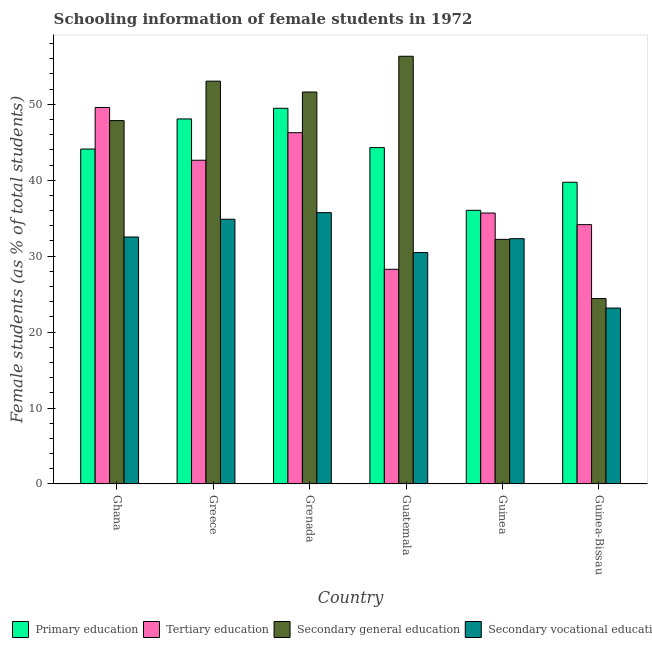Are the number of bars per tick equal to the number of legend labels?
Your answer should be very brief. Yes. Are the number of bars on each tick of the X-axis equal?
Make the answer very short. Yes. What is the label of the 6th group of bars from the left?
Give a very brief answer. Guinea-Bissau. In how many cases, is the number of bars for a given country not equal to the number of legend labels?
Your answer should be very brief. 0. What is the percentage of female students in secondary vocational education in Guinea?
Give a very brief answer. 32.31. Across all countries, what is the maximum percentage of female students in tertiary education?
Offer a very short reply. 49.59. Across all countries, what is the minimum percentage of female students in tertiary education?
Your response must be concise. 28.27. In which country was the percentage of female students in secondary education maximum?
Your answer should be compact. Guatemala. In which country was the percentage of female students in primary education minimum?
Provide a short and direct response. Guinea. What is the total percentage of female students in tertiary education in the graph?
Your response must be concise. 236.6. What is the difference between the percentage of female students in primary education in Greece and that in Guatemala?
Your answer should be compact. 3.78. What is the difference between the percentage of female students in primary education in Guinea and the percentage of female students in secondary education in Greece?
Offer a very short reply. -17.01. What is the average percentage of female students in primary education per country?
Ensure brevity in your answer.  43.62. What is the difference between the percentage of female students in primary education and percentage of female students in secondary education in Guinea-Bissau?
Give a very brief answer. 15.31. What is the ratio of the percentage of female students in primary education in Grenada to that in Guinea?
Give a very brief answer. 1.37. Is the percentage of female students in secondary education in Ghana less than that in Guinea-Bissau?
Make the answer very short. No. Is the difference between the percentage of female students in tertiary education in Ghana and Guatemala greater than the difference between the percentage of female students in primary education in Ghana and Guatemala?
Your answer should be compact. Yes. What is the difference between the highest and the second highest percentage of female students in tertiary education?
Provide a short and direct response. 3.32. What is the difference between the highest and the lowest percentage of female students in primary education?
Offer a very short reply. 13.44. In how many countries, is the percentage of female students in secondary education greater than the average percentage of female students in secondary education taken over all countries?
Provide a short and direct response. 4. Is the sum of the percentage of female students in secondary education in Grenada and Guinea greater than the maximum percentage of female students in primary education across all countries?
Make the answer very short. Yes. Is it the case that in every country, the sum of the percentage of female students in secondary vocational education and percentage of female students in secondary education is greater than the sum of percentage of female students in tertiary education and percentage of female students in primary education?
Offer a terse response. No. What does the 4th bar from the left in Greece represents?
Offer a terse response. Secondary vocational education. What does the 1st bar from the right in Guinea-Bissau represents?
Your response must be concise. Secondary vocational education. How many bars are there?
Offer a very short reply. 24. How many countries are there in the graph?
Offer a terse response. 6. Are the values on the major ticks of Y-axis written in scientific E-notation?
Give a very brief answer. No. Where does the legend appear in the graph?
Your response must be concise. Bottom left. How many legend labels are there?
Give a very brief answer. 4. What is the title of the graph?
Give a very brief answer. Schooling information of female students in 1972. What is the label or title of the Y-axis?
Offer a very short reply. Female students (as % of total students). What is the Female students (as % of total students) in Primary education in Ghana?
Provide a succinct answer. 44.11. What is the Female students (as % of total students) in Tertiary education in Ghana?
Give a very brief answer. 49.59. What is the Female students (as % of total students) of Secondary general education in Ghana?
Your answer should be very brief. 47.86. What is the Female students (as % of total students) of Secondary vocational education in Ghana?
Your answer should be compact. 32.53. What is the Female students (as % of total students) of Primary education in Greece?
Your answer should be very brief. 48.07. What is the Female students (as % of total students) in Tertiary education in Greece?
Provide a short and direct response. 42.64. What is the Female students (as % of total students) in Secondary general education in Greece?
Your response must be concise. 53.05. What is the Female students (as % of total students) of Secondary vocational education in Greece?
Offer a very short reply. 34.87. What is the Female students (as % of total students) of Primary education in Grenada?
Your answer should be very brief. 49.48. What is the Female students (as % of total students) of Tertiary education in Grenada?
Your response must be concise. 46.26. What is the Female students (as % of total students) in Secondary general education in Grenada?
Make the answer very short. 51.62. What is the Female students (as % of total students) in Secondary vocational education in Grenada?
Provide a short and direct response. 35.73. What is the Female students (as % of total students) of Primary education in Guatemala?
Ensure brevity in your answer.  44.3. What is the Female students (as % of total students) in Tertiary education in Guatemala?
Ensure brevity in your answer.  28.27. What is the Female students (as % of total students) of Secondary general education in Guatemala?
Offer a terse response. 56.33. What is the Female students (as % of total students) of Secondary vocational education in Guatemala?
Offer a terse response. 30.48. What is the Female students (as % of total students) of Primary education in Guinea?
Offer a very short reply. 36.04. What is the Female students (as % of total students) in Tertiary education in Guinea?
Your response must be concise. 35.68. What is the Female students (as % of total students) in Secondary general education in Guinea?
Make the answer very short. 32.21. What is the Female students (as % of total students) of Secondary vocational education in Guinea?
Offer a terse response. 32.31. What is the Female students (as % of total students) in Primary education in Guinea-Bissau?
Keep it short and to the point. 39.73. What is the Female students (as % of total students) in Tertiary education in Guinea-Bissau?
Provide a succinct answer. 34.15. What is the Female students (as % of total students) of Secondary general education in Guinea-Bissau?
Provide a short and direct response. 24.42. What is the Female students (as % of total students) of Secondary vocational education in Guinea-Bissau?
Offer a terse response. 23.17. Across all countries, what is the maximum Female students (as % of total students) in Primary education?
Your answer should be very brief. 49.48. Across all countries, what is the maximum Female students (as % of total students) of Tertiary education?
Make the answer very short. 49.59. Across all countries, what is the maximum Female students (as % of total students) in Secondary general education?
Your response must be concise. 56.33. Across all countries, what is the maximum Female students (as % of total students) of Secondary vocational education?
Offer a very short reply. 35.73. Across all countries, what is the minimum Female students (as % of total students) of Primary education?
Make the answer very short. 36.04. Across all countries, what is the minimum Female students (as % of total students) in Tertiary education?
Your answer should be compact. 28.27. Across all countries, what is the minimum Female students (as % of total students) of Secondary general education?
Give a very brief answer. 24.42. Across all countries, what is the minimum Female students (as % of total students) in Secondary vocational education?
Your answer should be very brief. 23.17. What is the total Female students (as % of total students) in Primary education in the graph?
Provide a short and direct response. 261.74. What is the total Female students (as % of total students) in Tertiary education in the graph?
Make the answer very short. 236.6. What is the total Female students (as % of total students) in Secondary general education in the graph?
Your response must be concise. 265.5. What is the total Female students (as % of total students) in Secondary vocational education in the graph?
Your answer should be compact. 189.08. What is the difference between the Female students (as % of total students) in Primary education in Ghana and that in Greece?
Offer a very short reply. -3.97. What is the difference between the Female students (as % of total students) in Tertiary education in Ghana and that in Greece?
Provide a succinct answer. 6.95. What is the difference between the Female students (as % of total students) in Secondary general education in Ghana and that in Greece?
Give a very brief answer. -5.19. What is the difference between the Female students (as % of total students) of Secondary vocational education in Ghana and that in Greece?
Offer a very short reply. -2.34. What is the difference between the Female students (as % of total students) of Primary education in Ghana and that in Grenada?
Your response must be concise. -5.37. What is the difference between the Female students (as % of total students) in Tertiary education in Ghana and that in Grenada?
Your answer should be very brief. 3.32. What is the difference between the Female students (as % of total students) of Secondary general education in Ghana and that in Grenada?
Your response must be concise. -3.76. What is the difference between the Female students (as % of total students) in Secondary vocational education in Ghana and that in Grenada?
Offer a terse response. -3.2. What is the difference between the Female students (as % of total students) of Primary education in Ghana and that in Guatemala?
Give a very brief answer. -0.19. What is the difference between the Female students (as % of total students) in Tertiary education in Ghana and that in Guatemala?
Your response must be concise. 21.31. What is the difference between the Female students (as % of total students) in Secondary general education in Ghana and that in Guatemala?
Offer a very short reply. -8.47. What is the difference between the Female students (as % of total students) of Secondary vocational education in Ghana and that in Guatemala?
Make the answer very short. 2.05. What is the difference between the Female students (as % of total students) of Primary education in Ghana and that in Guinea?
Provide a succinct answer. 8.07. What is the difference between the Female students (as % of total students) of Tertiary education in Ghana and that in Guinea?
Offer a terse response. 13.91. What is the difference between the Female students (as % of total students) in Secondary general education in Ghana and that in Guinea?
Provide a short and direct response. 15.64. What is the difference between the Female students (as % of total students) of Secondary vocational education in Ghana and that in Guinea?
Offer a very short reply. 0.22. What is the difference between the Female students (as % of total students) in Primary education in Ghana and that in Guinea-Bissau?
Make the answer very short. 4.37. What is the difference between the Female students (as % of total students) in Tertiary education in Ghana and that in Guinea-Bissau?
Your answer should be compact. 15.43. What is the difference between the Female students (as % of total students) of Secondary general education in Ghana and that in Guinea-Bissau?
Provide a succinct answer. 23.44. What is the difference between the Female students (as % of total students) of Secondary vocational education in Ghana and that in Guinea-Bissau?
Offer a very short reply. 9.36. What is the difference between the Female students (as % of total students) of Primary education in Greece and that in Grenada?
Your answer should be compact. -1.4. What is the difference between the Female students (as % of total students) in Tertiary education in Greece and that in Grenada?
Make the answer very short. -3.63. What is the difference between the Female students (as % of total students) in Secondary general education in Greece and that in Grenada?
Make the answer very short. 1.43. What is the difference between the Female students (as % of total students) in Secondary vocational education in Greece and that in Grenada?
Your answer should be compact. -0.87. What is the difference between the Female students (as % of total students) of Primary education in Greece and that in Guatemala?
Make the answer very short. 3.78. What is the difference between the Female students (as % of total students) in Tertiary education in Greece and that in Guatemala?
Your answer should be very brief. 14.36. What is the difference between the Female students (as % of total students) of Secondary general education in Greece and that in Guatemala?
Offer a very short reply. -3.28. What is the difference between the Female students (as % of total students) of Secondary vocational education in Greece and that in Guatemala?
Your response must be concise. 4.39. What is the difference between the Female students (as % of total students) of Primary education in Greece and that in Guinea?
Give a very brief answer. 12.03. What is the difference between the Female students (as % of total students) in Tertiary education in Greece and that in Guinea?
Provide a succinct answer. 6.95. What is the difference between the Female students (as % of total students) in Secondary general education in Greece and that in Guinea?
Offer a terse response. 20.84. What is the difference between the Female students (as % of total students) of Secondary vocational education in Greece and that in Guinea?
Your answer should be compact. 2.56. What is the difference between the Female students (as % of total students) in Primary education in Greece and that in Guinea-Bissau?
Give a very brief answer. 8.34. What is the difference between the Female students (as % of total students) in Tertiary education in Greece and that in Guinea-Bissau?
Ensure brevity in your answer.  8.48. What is the difference between the Female students (as % of total students) of Secondary general education in Greece and that in Guinea-Bissau?
Ensure brevity in your answer.  28.63. What is the difference between the Female students (as % of total students) in Secondary vocational education in Greece and that in Guinea-Bissau?
Give a very brief answer. 11.7. What is the difference between the Female students (as % of total students) in Primary education in Grenada and that in Guatemala?
Offer a very short reply. 5.18. What is the difference between the Female students (as % of total students) of Tertiary education in Grenada and that in Guatemala?
Provide a succinct answer. 17.99. What is the difference between the Female students (as % of total students) of Secondary general education in Grenada and that in Guatemala?
Offer a very short reply. -4.71. What is the difference between the Female students (as % of total students) of Secondary vocational education in Grenada and that in Guatemala?
Your answer should be very brief. 5.26. What is the difference between the Female students (as % of total students) in Primary education in Grenada and that in Guinea?
Provide a short and direct response. 13.44. What is the difference between the Female students (as % of total students) of Tertiary education in Grenada and that in Guinea?
Offer a terse response. 10.58. What is the difference between the Female students (as % of total students) of Secondary general education in Grenada and that in Guinea?
Make the answer very short. 19.41. What is the difference between the Female students (as % of total students) in Secondary vocational education in Grenada and that in Guinea?
Provide a succinct answer. 3.43. What is the difference between the Female students (as % of total students) in Primary education in Grenada and that in Guinea-Bissau?
Provide a succinct answer. 9.74. What is the difference between the Female students (as % of total students) of Tertiary education in Grenada and that in Guinea-Bissau?
Offer a terse response. 12.11. What is the difference between the Female students (as % of total students) of Secondary general education in Grenada and that in Guinea-Bissau?
Make the answer very short. 27.2. What is the difference between the Female students (as % of total students) of Secondary vocational education in Grenada and that in Guinea-Bissau?
Your response must be concise. 12.56. What is the difference between the Female students (as % of total students) in Primary education in Guatemala and that in Guinea?
Make the answer very short. 8.26. What is the difference between the Female students (as % of total students) of Tertiary education in Guatemala and that in Guinea?
Your response must be concise. -7.41. What is the difference between the Female students (as % of total students) of Secondary general education in Guatemala and that in Guinea?
Provide a short and direct response. 24.11. What is the difference between the Female students (as % of total students) of Secondary vocational education in Guatemala and that in Guinea?
Your answer should be compact. -1.83. What is the difference between the Female students (as % of total students) of Primary education in Guatemala and that in Guinea-Bissau?
Make the answer very short. 4.56. What is the difference between the Female students (as % of total students) in Tertiary education in Guatemala and that in Guinea-Bissau?
Offer a terse response. -5.88. What is the difference between the Female students (as % of total students) of Secondary general education in Guatemala and that in Guinea-Bissau?
Your response must be concise. 31.91. What is the difference between the Female students (as % of total students) in Secondary vocational education in Guatemala and that in Guinea-Bissau?
Your answer should be compact. 7.31. What is the difference between the Female students (as % of total students) in Primary education in Guinea and that in Guinea-Bissau?
Give a very brief answer. -3.69. What is the difference between the Female students (as % of total students) in Tertiary education in Guinea and that in Guinea-Bissau?
Your answer should be very brief. 1.53. What is the difference between the Female students (as % of total students) in Secondary general education in Guinea and that in Guinea-Bissau?
Make the answer very short. 7.79. What is the difference between the Female students (as % of total students) of Secondary vocational education in Guinea and that in Guinea-Bissau?
Keep it short and to the point. 9.14. What is the difference between the Female students (as % of total students) of Primary education in Ghana and the Female students (as % of total students) of Tertiary education in Greece?
Provide a succinct answer. 1.47. What is the difference between the Female students (as % of total students) in Primary education in Ghana and the Female students (as % of total students) in Secondary general education in Greece?
Your answer should be compact. -8.94. What is the difference between the Female students (as % of total students) in Primary education in Ghana and the Female students (as % of total students) in Secondary vocational education in Greece?
Your answer should be compact. 9.24. What is the difference between the Female students (as % of total students) of Tertiary education in Ghana and the Female students (as % of total students) of Secondary general education in Greece?
Your answer should be compact. -3.46. What is the difference between the Female students (as % of total students) in Tertiary education in Ghana and the Female students (as % of total students) in Secondary vocational education in Greece?
Make the answer very short. 14.72. What is the difference between the Female students (as % of total students) of Secondary general education in Ghana and the Female students (as % of total students) of Secondary vocational education in Greece?
Your response must be concise. 12.99. What is the difference between the Female students (as % of total students) in Primary education in Ghana and the Female students (as % of total students) in Tertiary education in Grenada?
Offer a terse response. -2.16. What is the difference between the Female students (as % of total students) of Primary education in Ghana and the Female students (as % of total students) of Secondary general education in Grenada?
Offer a very short reply. -7.51. What is the difference between the Female students (as % of total students) of Primary education in Ghana and the Female students (as % of total students) of Secondary vocational education in Grenada?
Make the answer very short. 8.38. What is the difference between the Female students (as % of total students) in Tertiary education in Ghana and the Female students (as % of total students) in Secondary general education in Grenada?
Offer a very short reply. -2.03. What is the difference between the Female students (as % of total students) of Tertiary education in Ghana and the Female students (as % of total students) of Secondary vocational education in Grenada?
Make the answer very short. 13.85. What is the difference between the Female students (as % of total students) of Secondary general education in Ghana and the Female students (as % of total students) of Secondary vocational education in Grenada?
Give a very brief answer. 12.13. What is the difference between the Female students (as % of total students) of Primary education in Ghana and the Female students (as % of total students) of Tertiary education in Guatemala?
Your answer should be very brief. 15.83. What is the difference between the Female students (as % of total students) of Primary education in Ghana and the Female students (as % of total students) of Secondary general education in Guatemala?
Give a very brief answer. -12.22. What is the difference between the Female students (as % of total students) of Primary education in Ghana and the Female students (as % of total students) of Secondary vocational education in Guatemala?
Make the answer very short. 13.63. What is the difference between the Female students (as % of total students) in Tertiary education in Ghana and the Female students (as % of total students) in Secondary general education in Guatemala?
Your response must be concise. -6.74. What is the difference between the Female students (as % of total students) in Tertiary education in Ghana and the Female students (as % of total students) in Secondary vocational education in Guatemala?
Your answer should be compact. 19.11. What is the difference between the Female students (as % of total students) of Secondary general education in Ghana and the Female students (as % of total students) of Secondary vocational education in Guatemala?
Keep it short and to the point. 17.38. What is the difference between the Female students (as % of total students) in Primary education in Ghana and the Female students (as % of total students) in Tertiary education in Guinea?
Ensure brevity in your answer.  8.43. What is the difference between the Female students (as % of total students) of Primary education in Ghana and the Female students (as % of total students) of Secondary general education in Guinea?
Your answer should be compact. 11.89. What is the difference between the Female students (as % of total students) of Primary education in Ghana and the Female students (as % of total students) of Secondary vocational education in Guinea?
Your answer should be compact. 11.8. What is the difference between the Female students (as % of total students) in Tertiary education in Ghana and the Female students (as % of total students) in Secondary general education in Guinea?
Keep it short and to the point. 17.37. What is the difference between the Female students (as % of total students) of Tertiary education in Ghana and the Female students (as % of total students) of Secondary vocational education in Guinea?
Provide a succinct answer. 17.28. What is the difference between the Female students (as % of total students) of Secondary general education in Ghana and the Female students (as % of total students) of Secondary vocational education in Guinea?
Your response must be concise. 15.55. What is the difference between the Female students (as % of total students) in Primary education in Ghana and the Female students (as % of total students) in Tertiary education in Guinea-Bissau?
Keep it short and to the point. 9.95. What is the difference between the Female students (as % of total students) of Primary education in Ghana and the Female students (as % of total students) of Secondary general education in Guinea-Bissau?
Your answer should be very brief. 19.69. What is the difference between the Female students (as % of total students) in Primary education in Ghana and the Female students (as % of total students) in Secondary vocational education in Guinea-Bissau?
Make the answer very short. 20.94. What is the difference between the Female students (as % of total students) in Tertiary education in Ghana and the Female students (as % of total students) in Secondary general education in Guinea-Bissau?
Provide a succinct answer. 25.16. What is the difference between the Female students (as % of total students) in Tertiary education in Ghana and the Female students (as % of total students) in Secondary vocational education in Guinea-Bissau?
Offer a very short reply. 26.42. What is the difference between the Female students (as % of total students) of Secondary general education in Ghana and the Female students (as % of total students) of Secondary vocational education in Guinea-Bissau?
Your answer should be compact. 24.69. What is the difference between the Female students (as % of total students) in Primary education in Greece and the Female students (as % of total students) in Tertiary education in Grenada?
Offer a very short reply. 1.81. What is the difference between the Female students (as % of total students) of Primary education in Greece and the Female students (as % of total students) of Secondary general education in Grenada?
Make the answer very short. -3.55. What is the difference between the Female students (as % of total students) of Primary education in Greece and the Female students (as % of total students) of Secondary vocational education in Grenada?
Ensure brevity in your answer.  12.34. What is the difference between the Female students (as % of total students) in Tertiary education in Greece and the Female students (as % of total students) in Secondary general education in Grenada?
Your answer should be very brief. -8.99. What is the difference between the Female students (as % of total students) of Tertiary education in Greece and the Female students (as % of total students) of Secondary vocational education in Grenada?
Offer a terse response. 6.9. What is the difference between the Female students (as % of total students) in Secondary general education in Greece and the Female students (as % of total students) in Secondary vocational education in Grenada?
Make the answer very short. 17.32. What is the difference between the Female students (as % of total students) of Primary education in Greece and the Female students (as % of total students) of Tertiary education in Guatemala?
Ensure brevity in your answer.  19.8. What is the difference between the Female students (as % of total students) of Primary education in Greece and the Female students (as % of total students) of Secondary general education in Guatemala?
Provide a short and direct response. -8.26. What is the difference between the Female students (as % of total students) of Primary education in Greece and the Female students (as % of total students) of Secondary vocational education in Guatemala?
Ensure brevity in your answer.  17.6. What is the difference between the Female students (as % of total students) in Tertiary education in Greece and the Female students (as % of total students) in Secondary general education in Guatemala?
Give a very brief answer. -13.69. What is the difference between the Female students (as % of total students) in Tertiary education in Greece and the Female students (as % of total students) in Secondary vocational education in Guatemala?
Your answer should be compact. 12.16. What is the difference between the Female students (as % of total students) in Secondary general education in Greece and the Female students (as % of total students) in Secondary vocational education in Guatemala?
Offer a terse response. 22.58. What is the difference between the Female students (as % of total students) of Primary education in Greece and the Female students (as % of total students) of Tertiary education in Guinea?
Ensure brevity in your answer.  12.39. What is the difference between the Female students (as % of total students) of Primary education in Greece and the Female students (as % of total students) of Secondary general education in Guinea?
Offer a terse response. 15.86. What is the difference between the Female students (as % of total students) in Primary education in Greece and the Female students (as % of total students) in Secondary vocational education in Guinea?
Provide a short and direct response. 15.77. What is the difference between the Female students (as % of total students) in Tertiary education in Greece and the Female students (as % of total students) in Secondary general education in Guinea?
Your answer should be very brief. 10.42. What is the difference between the Female students (as % of total students) in Tertiary education in Greece and the Female students (as % of total students) in Secondary vocational education in Guinea?
Make the answer very short. 10.33. What is the difference between the Female students (as % of total students) of Secondary general education in Greece and the Female students (as % of total students) of Secondary vocational education in Guinea?
Provide a short and direct response. 20.75. What is the difference between the Female students (as % of total students) of Primary education in Greece and the Female students (as % of total students) of Tertiary education in Guinea-Bissau?
Your response must be concise. 13.92. What is the difference between the Female students (as % of total students) in Primary education in Greece and the Female students (as % of total students) in Secondary general education in Guinea-Bissau?
Your answer should be very brief. 23.65. What is the difference between the Female students (as % of total students) in Primary education in Greece and the Female students (as % of total students) in Secondary vocational education in Guinea-Bissau?
Your answer should be compact. 24.91. What is the difference between the Female students (as % of total students) of Tertiary education in Greece and the Female students (as % of total students) of Secondary general education in Guinea-Bissau?
Give a very brief answer. 18.21. What is the difference between the Female students (as % of total students) in Tertiary education in Greece and the Female students (as % of total students) in Secondary vocational education in Guinea-Bissau?
Make the answer very short. 19.47. What is the difference between the Female students (as % of total students) of Secondary general education in Greece and the Female students (as % of total students) of Secondary vocational education in Guinea-Bissau?
Give a very brief answer. 29.88. What is the difference between the Female students (as % of total students) of Primary education in Grenada and the Female students (as % of total students) of Tertiary education in Guatemala?
Make the answer very short. 21.2. What is the difference between the Female students (as % of total students) of Primary education in Grenada and the Female students (as % of total students) of Secondary general education in Guatemala?
Offer a terse response. -6.85. What is the difference between the Female students (as % of total students) of Primary education in Grenada and the Female students (as % of total students) of Secondary vocational education in Guatemala?
Provide a succinct answer. 19. What is the difference between the Female students (as % of total students) of Tertiary education in Grenada and the Female students (as % of total students) of Secondary general education in Guatemala?
Give a very brief answer. -10.07. What is the difference between the Female students (as % of total students) of Tertiary education in Grenada and the Female students (as % of total students) of Secondary vocational education in Guatemala?
Ensure brevity in your answer.  15.79. What is the difference between the Female students (as % of total students) of Secondary general education in Grenada and the Female students (as % of total students) of Secondary vocational education in Guatemala?
Your answer should be compact. 21.15. What is the difference between the Female students (as % of total students) in Primary education in Grenada and the Female students (as % of total students) in Tertiary education in Guinea?
Your response must be concise. 13.8. What is the difference between the Female students (as % of total students) of Primary education in Grenada and the Female students (as % of total students) of Secondary general education in Guinea?
Your response must be concise. 17.26. What is the difference between the Female students (as % of total students) in Primary education in Grenada and the Female students (as % of total students) in Secondary vocational education in Guinea?
Ensure brevity in your answer.  17.17. What is the difference between the Female students (as % of total students) in Tertiary education in Grenada and the Female students (as % of total students) in Secondary general education in Guinea?
Provide a short and direct response. 14.05. What is the difference between the Female students (as % of total students) of Tertiary education in Grenada and the Female students (as % of total students) of Secondary vocational education in Guinea?
Your answer should be compact. 13.96. What is the difference between the Female students (as % of total students) in Secondary general education in Grenada and the Female students (as % of total students) in Secondary vocational education in Guinea?
Offer a very short reply. 19.32. What is the difference between the Female students (as % of total students) of Primary education in Grenada and the Female students (as % of total students) of Tertiary education in Guinea-Bissau?
Provide a succinct answer. 15.32. What is the difference between the Female students (as % of total students) of Primary education in Grenada and the Female students (as % of total students) of Secondary general education in Guinea-Bissau?
Your response must be concise. 25.06. What is the difference between the Female students (as % of total students) of Primary education in Grenada and the Female students (as % of total students) of Secondary vocational education in Guinea-Bissau?
Your response must be concise. 26.31. What is the difference between the Female students (as % of total students) in Tertiary education in Grenada and the Female students (as % of total students) in Secondary general education in Guinea-Bissau?
Your response must be concise. 21.84. What is the difference between the Female students (as % of total students) of Tertiary education in Grenada and the Female students (as % of total students) of Secondary vocational education in Guinea-Bissau?
Provide a short and direct response. 23.1. What is the difference between the Female students (as % of total students) in Secondary general education in Grenada and the Female students (as % of total students) in Secondary vocational education in Guinea-Bissau?
Offer a very short reply. 28.45. What is the difference between the Female students (as % of total students) in Primary education in Guatemala and the Female students (as % of total students) in Tertiary education in Guinea?
Keep it short and to the point. 8.62. What is the difference between the Female students (as % of total students) in Primary education in Guatemala and the Female students (as % of total students) in Secondary general education in Guinea?
Keep it short and to the point. 12.08. What is the difference between the Female students (as % of total students) in Primary education in Guatemala and the Female students (as % of total students) in Secondary vocational education in Guinea?
Provide a succinct answer. 11.99. What is the difference between the Female students (as % of total students) in Tertiary education in Guatemala and the Female students (as % of total students) in Secondary general education in Guinea?
Keep it short and to the point. -3.94. What is the difference between the Female students (as % of total students) of Tertiary education in Guatemala and the Female students (as % of total students) of Secondary vocational education in Guinea?
Offer a terse response. -4.03. What is the difference between the Female students (as % of total students) of Secondary general education in Guatemala and the Female students (as % of total students) of Secondary vocational education in Guinea?
Your answer should be very brief. 24.02. What is the difference between the Female students (as % of total students) of Primary education in Guatemala and the Female students (as % of total students) of Tertiary education in Guinea-Bissau?
Give a very brief answer. 10.14. What is the difference between the Female students (as % of total students) of Primary education in Guatemala and the Female students (as % of total students) of Secondary general education in Guinea-Bissau?
Provide a succinct answer. 19.88. What is the difference between the Female students (as % of total students) of Primary education in Guatemala and the Female students (as % of total students) of Secondary vocational education in Guinea-Bissau?
Provide a succinct answer. 21.13. What is the difference between the Female students (as % of total students) of Tertiary education in Guatemala and the Female students (as % of total students) of Secondary general education in Guinea-Bissau?
Keep it short and to the point. 3.85. What is the difference between the Female students (as % of total students) in Tertiary education in Guatemala and the Female students (as % of total students) in Secondary vocational education in Guinea-Bissau?
Offer a terse response. 5.11. What is the difference between the Female students (as % of total students) of Secondary general education in Guatemala and the Female students (as % of total students) of Secondary vocational education in Guinea-Bissau?
Offer a very short reply. 33.16. What is the difference between the Female students (as % of total students) in Primary education in Guinea and the Female students (as % of total students) in Tertiary education in Guinea-Bissau?
Your answer should be very brief. 1.89. What is the difference between the Female students (as % of total students) in Primary education in Guinea and the Female students (as % of total students) in Secondary general education in Guinea-Bissau?
Your answer should be compact. 11.62. What is the difference between the Female students (as % of total students) in Primary education in Guinea and the Female students (as % of total students) in Secondary vocational education in Guinea-Bissau?
Provide a short and direct response. 12.87. What is the difference between the Female students (as % of total students) in Tertiary education in Guinea and the Female students (as % of total students) in Secondary general education in Guinea-Bissau?
Your answer should be compact. 11.26. What is the difference between the Female students (as % of total students) in Tertiary education in Guinea and the Female students (as % of total students) in Secondary vocational education in Guinea-Bissau?
Offer a very short reply. 12.51. What is the difference between the Female students (as % of total students) in Secondary general education in Guinea and the Female students (as % of total students) in Secondary vocational education in Guinea-Bissau?
Your answer should be very brief. 9.05. What is the average Female students (as % of total students) of Primary education per country?
Provide a short and direct response. 43.62. What is the average Female students (as % of total students) of Tertiary education per country?
Your answer should be compact. 39.43. What is the average Female students (as % of total students) of Secondary general education per country?
Provide a succinct answer. 44.25. What is the average Female students (as % of total students) of Secondary vocational education per country?
Make the answer very short. 31.51. What is the difference between the Female students (as % of total students) of Primary education and Female students (as % of total students) of Tertiary education in Ghana?
Your answer should be compact. -5.48. What is the difference between the Female students (as % of total students) of Primary education and Female students (as % of total students) of Secondary general education in Ghana?
Your response must be concise. -3.75. What is the difference between the Female students (as % of total students) of Primary education and Female students (as % of total students) of Secondary vocational education in Ghana?
Provide a short and direct response. 11.58. What is the difference between the Female students (as % of total students) of Tertiary education and Female students (as % of total students) of Secondary general education in Ghana?
Give a very brief answer. 1.73. What is the difference between the Female students (as % of total students) of Tertiary education and Female students (as % of total students) of Secondary vocational education in Ghana?
Make the answer very short. 17.06. What is the difference between the Female students (as % of total students) of Secondary general education and Female students (as % of total students) of Secondary vocational education in Ghana?
Give a very brief answer. 15.33. What is the difference between the Female students (as % of total students) in Primary education and Female students (as % of total students) in Tertiary education in Greece?
Ensure brevity in your answer.  5.44. What is the difference between the Female students (as % of total students) of Primary education and Female students (as % of total students) of Secondary general education in Greece?
Make the answer very short. -4.98. What is the difference between the Female students (as % of total students) of Primary education and Female students (as % of total students) of Secondary vocational education in Greece?
Provide a short and direct response. 13.21. What is the difference between the Female students (as % of total students) of Tertiary education and Female students (as % of total students) of Secondary general education in Greece?
Provide a short and direct response. -10.42. What is the difference between the Female students (as % of total students) in Tertiary education and Female students (as % of total students) in Secondary vocational education in Greece?
Your response must be concise. 7.77. What is the difference between the Female students (as % of total students) of Secondary general education and Female students (as % of total students) of Secondary vocational education in Greece?
Your answer should be compact. 18.18. What is the difference between the Female students (as % of total students) in Primary education and Female students (as % of total students) in Tertiary education in Grenada?
Your answer should be very brief. 3.21. What is the difference between the Female students (as % of total students) in Primary education and Female students (as % of total students) in Secondary general education in Grenada?
Give a very brief answer. -2.14. What is the difference between the Female students (as % of total students) in Primary education and Female students (as % of total students) in Secondary vocational education in Grenada?
Keep it short and to the point. 13.74. What is the difference between the Female students (as % of total students) of Tertiary education and Female students (as % of total students) of Secondary general education in Grenada?
Your response must be concise. -5.36. What is the difference between the Female students (as % of total students) of Tertiary education and Female students (as % of total students) of Secondary vocational education in Grenada?
Your answer should be compact. 10.53. What is the difference between the Female students (as % of total students) of Secondary general education and Female students (as % of total students) of Secondary vocational education in Grenada?
Your answer should be compact. 15.89. What is the difference between the Female students (as % of total students) of Primary education and Female students (as % of total students) of Tertiary education in Guatemala?
Your response must be concise. 16.02. What is the difference between the Female students (as % of total students) in Primary education and Female students (as % of total students) in Secondary general education in Guatemala?
Your answer should be very brief. -12.03. What is the difference between the Female students (as % of total students) in Primary education and Female students (as % of total students) in Secondary vocational education in Guatemala?
Ensure brevity in your answer.  13.82. What is the difference between the Female students (as % of total students) of Tertiary education and Female students (as % of total students) of Secondary general education in Guatemala?
Provide a short and direct response. -28.05. What is the difference between the Female students (as % of total students) in Tertiary education and Female students (as % of total students) in Secondary vocational education in Guatemala?
Provide a succinct answer. -2.2. What is the difference between the Female students (as % of total students) of Secondary general education and Female students (as % of total students) of Secondary vocational education in Guatemala?
Provide a short and direct response. 25.85. What is the difference between the Female students (as % of total students) of Primary education and Female students (as % of total students) of Tertiary education in Guinea?
Provide a short and direct response. 0.36. What is the difference between the Female students (as % of total students) of Primary education and Female students (as % of total students) of Secondary general education in Guinea?
Provide a succinct answer. 3.83. What is the difference between the Female students (as % of total students) of Primary education and Female students (as % of total students) of Secondary vocational education in Guinea?
Your answer should be compact. 3.74. What is the difference between the Female students (as % of total students) of Tertiary education and Female students (as % of total students) of Secondary general education in Guinea?
Your answer should be very brief. 3.47. What is the difference between the Female students (as % of total students) in Tertiary education and Female students (as % of total students) in Secondary vocational education in Guinea?
Give a very brief answer. 3.38. What is the difference between the Female students (as % of total students) of Secondary general education and Female students (as % of total students) of Secondary vocational education in Guinea?
Offer a very short reply. -0.09. What is the difference between the Female students (as % of total students) of Primary education and Female students (as % of total students) of Tertiary education in Guinea-Bissau?
Offer a terse response. 5.58. What is the difference between the Female students (as % of total students) of Primary education and Female students (as % of total students) of Secondary general education in Guinea-Bissau?
Offer a very short reply. 15.31. What is the difference between the Female students (as % of total students) in Primary education and Female students (as % of total students) in Secondary vocational education in Guinea-Bissau?
Keep it short and to the point. 16.57. What is the difference between the Female students (as % of total students) of Tertiary education and Female students (as % of total students) of Secondary general education in Guinea-Bissau?
Your answer should be very brief. 9.73. What is the difference between the Female students (as % of total students) in Tertiary education and Female students (as % of total students) in Secondary vocational education in Guinea-Bissau?
Provide a short and direct response. 10.99. What is the difference between the Female students (as % of total students) of Secondary general education and Female students (as % of total students) of Secondary vocational education in Guinea-Bissau?
Provide a short and direct response. 1.25. What is the ratio of the Female students (as % of total students) in Primary education in Ghana to that in Greece?
Your answer should be compact. 0.92. What is the ratio of the Female students (as % of total students) of Tertiary education in Ghana to that in Greece?
Your answer should be very brief. 1.16. What is the ratio of the Female students (as % of total students) of Secondary general education in Ghana to that in Greece?
Keep it short and to the point. 0.9. What is the ratio of the Female students (as % of total students) in Secondary vocational education in Ghana to that in Greece?
Give a very brief answer. 0.93. What is the ratio of the Female students (as % of total students) in Primary education in Ghana to that in Grenada?
Keep it short and to the point. 0.89. What is the ratio of the Female students (as % of total students) in Tertiary education in Ghana to that in Grenada?
Give a very brief answer. 1.07. What is the ratio of the Female students (as % of total students) of Secondary general education in Ghana to that in Grenada?
Your answer should be compact. 0.93. What is the ratio of the Female students (as % of total students) of Secondary vocational education in Ghana to that in Grenada?
Your answer should be compact. 0.91. What is the ratio of the Female students (as % of total students) in Tertiary education in Ghana to that in Guatemala?
Provide a short and direct response. 1.75. What is the ratio of the Female students (as % of total students) of Secondary general education in Ghana to that in Guatemala?
Your answer should be very brief. 0.85. What is the ratio of the Female students (as % of total students) of Secondary vocational education in Ghana to that in Guatemala?
Provide a succinct answer. 1.07. What is the ratio of the Female students (as % of total students) of Primary education in Ghana to that in Guinea?
Your response must be concise. 1.22. What is the ratio of the Female students (as % of total students) in Tertiary education in Ghana to that in Guinea?
Ensure brevity in your answer.  1.39. What is the ratio of the Female students (as % of total students) in Secondary general education in Ghana to that in Guinea?
Offer a very short reply. 1.49. What is the ratio of the Female students (as % of total students) of Secondary vocational education in Ghana to that in Guinea?
Provide a short and direct response. 1.01. What is the ratio of the Female students (as % of total students) of Primary education in Ghana to that in Guinea-Bissau?
Offer a terse response. 1.11. What is the ratio of the Female students (as % of total students) of Tertiary education in Ghana to that in Guinea-Bissau?
Keep it short and to the point. 1.45. What is the ratio of the Female students (as % of total students) in Secondary general education in Ghana to that in Guinea-Bissau?
Provide a succinct answer. 1.96. What is the ratio of the Female students (as % of total students) of Secondary vocational education in Ghana to that in Guinea-Bissau?
Keep it short and to the point. 1.4. What is the ratio of the Female students (as % of total students) of Primary education in Greece to that in Grenada?
Provide a short and direct response. 0.97. What is the ratio of the Female students (as % of total students) in Tertiary education in Greece to that in Grenada?
Offer a terse response. 0.92. What is the ratio of the Female students (as % of total students) in Secondary general education in Greece to that in Grenada?
Keep it short and to the point. 1.03. What is the ratio of the Female students (as % of total students) in Secondary vocational education in Greece to that in Grenada?
Give a very brief answer. 0.98. What is the ratio of the Female students (as % of total students) in Primary education in Greece to that in Guatemala?
Offer a terse response. 1.09. What is the ratio of the Female students (as % of total students) of Tertiary education in Greece to that in Guatemala?
Ensure brevity in your answer.  1.51. What is the ratio of the Female students (as % of total students) in Secondary general education in Greece to that in Guatemala?
Offer a very short reply. 0.94. What is the ratio of the Female students (as % of total students) in Secondary vocational education in Greece to that in Guatemala?
Offer a very short reply. 1.14. What is the ratio of the Female students (as % of total students) of Primary education in Greece to that in Guinea?
Your answer should be compact. 1.33. What is the ratio of the Female students (as % of total students) of Tertiary education in Greece to that in Guinea?
Make the answer very short. 1.19. What is the ratio of the Female students (as % of total students) of Secondary general education in Greece to that in Guinea?
Provide a succinct answer. 1.65. What is the ratio of the Female students (as % of total students) in Secondary vocational education in Greece to that in Guinea?
Your answer should be compact. 1.08. What is the ratio of the Female students (as % of total students) in Primary education in Greece to that in Guinea-Bissau?
Keep it short and to the point. 1.21. What is the ratio of the Female students (as % of total students) of Tertiary education in Greece to that in Guinea-Bissau?
Your answer should be very brief. 1.25. What is the ratio of the Female students (as % of total students) in Secondary general education in Greece to that in Guinea-Bissau?
Provide a succinct answer. 2.17. What is the ratio of the Female students (as % of total students) in Secondary vocational education in Greece to that in Guinea-Bissau?
Provide a short and direct response. 1.5. What is the ratio of the Female students (as % of total students) in Primary education in Grenada to that in Guatemala?
Your response must be concise. 1.12. What is the ratio of the Female students (as % of total students) in Tertiary education in Grenada to that in Guatemala?
Keep it short and to the point. 1.64. What is the ratio of the Female students (as % of total students) of Secondary general education in Grenada to that in Guatemala?
Ensure brevity in your answer.  0.92. What is the ratio of the Female students (as % of total students) of Secondary vocational education in Grenada to that in Guatemala?
Provide a short and direct response. 1.17. What is the ratio of the Female students (as % of total students) in Primary education in Grenada to that in Guinea?
Offer a terse response. 1.37. What is the ratio of the Female students (as % of total students) in Tertiary education in Grenada to that in Guinea?
Your response must be concise. 1.3. What is the ratio of the Female students (as % of total students) of Secondary general education in Grenada to that in Guinea?
Provide a short and direct response. 1.6. What is the ratio of the Female students (as % of total students) of Secondary vocational education in Grenada to that in Guinea?
Your answer should be compact. 1.11. What is the ratio of the Female students (as % of total students) in Primary education in Grenada to that in Guinea-Bissau?
Keep it short and to the point. 1.25. What is the ratio of the Female students (as % of total students) in Tertiary education in Grenada to that in Guinea-Bissau?
Your answer should be very brief. 1.35. What is the ratio of the Female students (as % of total students) of Secondary general education in Grenada to that in Guinea-Bissau?
Keep it short and to the point. 2.11. What is the ratio of the Female students (as % of total students) of Secondary vocational education in Grenada to that in Guinea-Bissau?
Ensure brevity in your answer.  1.54. What is the ratio of the Female students (as % of total students) in Primary education in Guatemala to that in Guinea?
Your answer should be very brief. 1.23. What is the ratio of the Female students (as % of total students) of Tertiary education in Guatemala to that in Guinea?
Your response must be concise. 0.79. What is the ratio of the Female students (as % of total students) in Secondary general education in Guatemala to that in Guinea?
Give a very brief answer. 1.75. What is the ratio of the Female students (as % of total students) of Secondary vocational education in Guatemala to that in Guinea?
Your response must be concise. 0.94. What is the ratio of the Female students (as % of total students) in Primary education in Guatemala to that in Guinea-Bissau?
Give a very brief answer. 1.11. What is the ratio of the Female students (as % of total students) of Tertiary education in Guatemala to that in Guinea-Bissau?
Your response must be concise. 0.83. What is the ratio of the Female students (as % of total students) in Secondary general education in Guatemala to that in Guinea-Bissau?
Your answer should be very brief. 2.31. What is the ratio of the Female students (as % of total students) of Secondary vocational education in Guatemala to that in Guinea-Bissau?
Your response must be concise. 1.32. What is the ratio of the Female students (as % of total students) of Primary education in Guinea to that in Guinea-Bissau?
Offer a terse response. 0.91. What is the ratio of the Female students (as % of total students) of Tertiary education in Guinea to that in Guinea-Bissau?
Offer a terse response. 1.04. What is the ratio of the Female students (as % of total students) of Secondary general education in Guinea to that in Guinea-Bissau?
Your answer should be very brief. 1.32. What is the ratio of the Female students (as % of total students) in Secondary vocational education in Guinea to that in Guinea-Bissau?
Your response must be concise. 1.39. What is the difference between the highest and the second highest Female students (as % of total students) of Primary education?
Offer a very short reply. 1.4. What is the difference between the highest and the second highest Female students (as % of total students) of Tertiary education?
Offer a very short reply. 3.32. What is the difference between the highest and the second highest Female students (as % of total students) of Secondary general education?
Keep it short and to the point. 3.28. What is the difference between the highest and the second highest Female students (as % of total students) in Secondary vocational education?
Provide a short and direct response. 0.87. What is the difference between the highest and the lowest Female students (as % of total students) in Primary education?
Your response must be concise. 13.44. What is the difference between the highest and the lowest Female students (as % of total students) of Tertiary education?
Provide a succinct answer. 21.31. What is the difference between the highest and the lowest Female students (as % of total students) in Secondary general education?
Give a very brief answer. 31.91. What is the difference between the highest and the lowest Female students (as % of total students) in Secondary vocational education?
Keep it short and to the point. 12.56. 